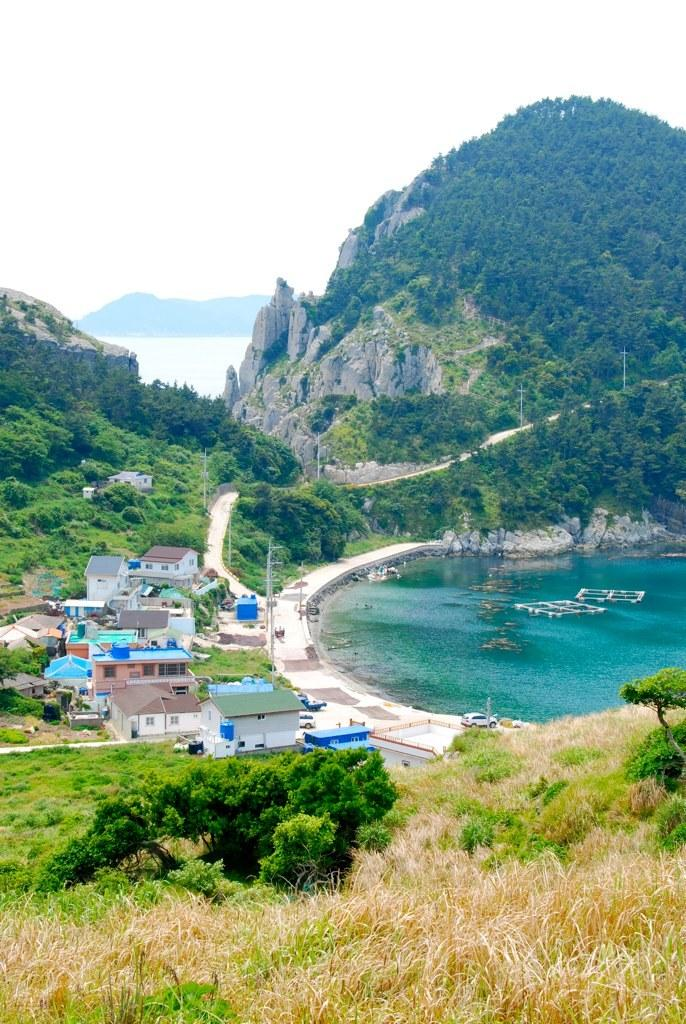What type of natural elements can be seen in the image? There are trees and mountains visible in the image. What type of man-made structures are present in the image? There are buildings with windows in the image. What type of transportation is visible in the image? There are vehicles in the image. What type of natural feature can be seen in the distance? There is water visible in the image. What else can be seen in the image besides the natural and man-made elements? There are objects in the image. What is visible in the background of the image? The sky is visible in the background of the image. What type of friction can be seen between the twig and the baseball in the image? There is no twig or baseball present in the image. How does the friction between the twig and the baseball affect the movement of the baseball in the image? There is no twig or baseball present in the image, so it is not possible to determine the effect of friction on the movement of the baseball. 